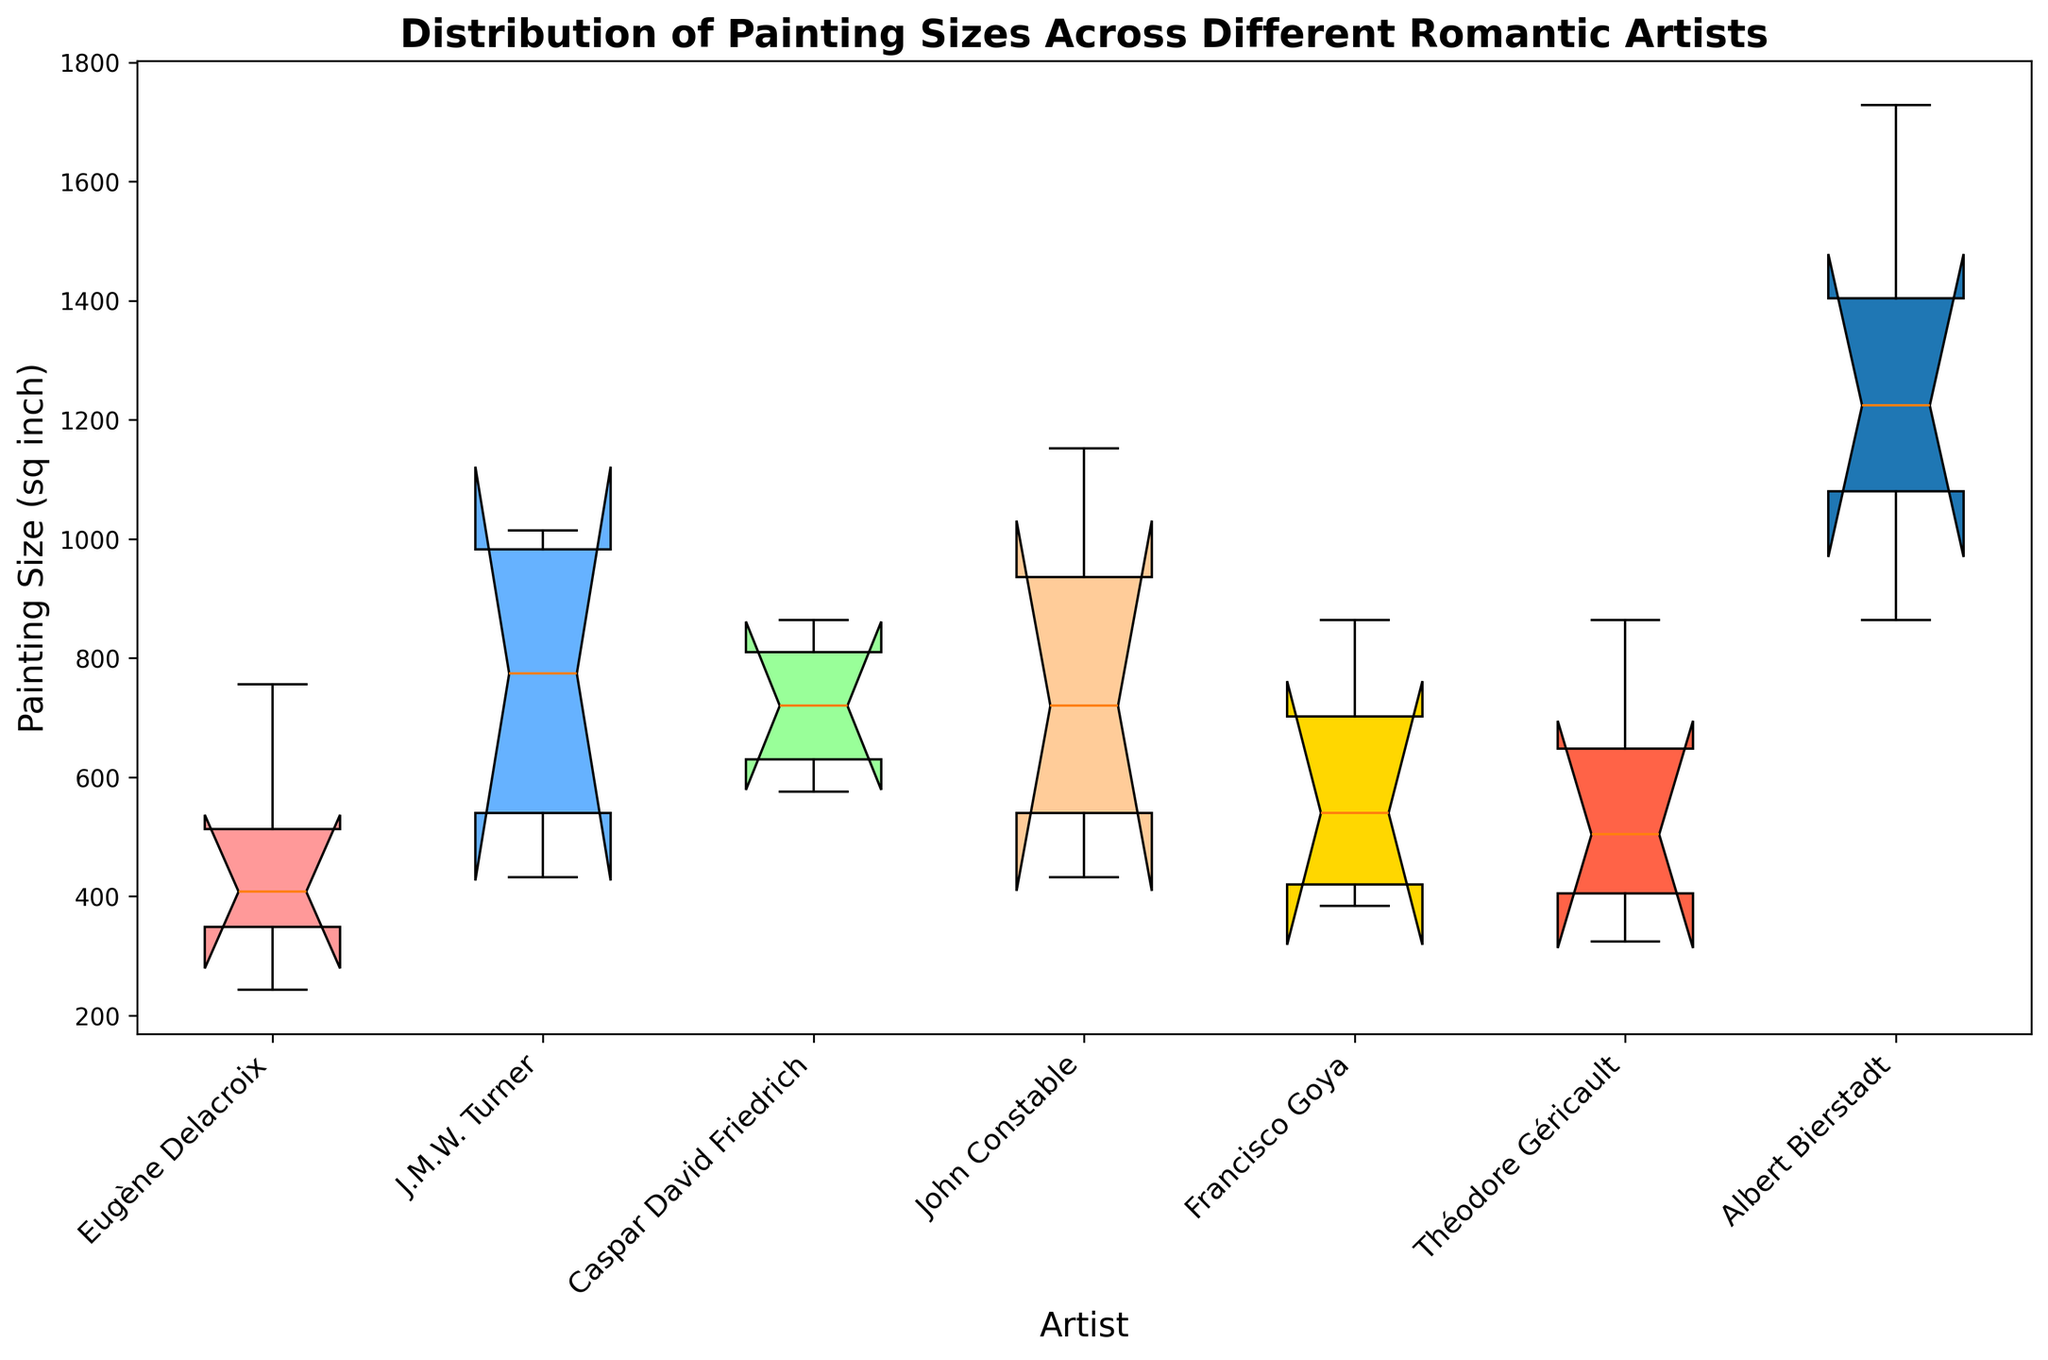What is the median painting size for Eugène Delacroix? To find the median size for Eugène Delacroix, look for the middle value in the sorted list of sizes. The sizes are [243, 384, 432, 756]. Since there are four values, the median is the average of the two middle values: (384 + 432) / 2 = 408.
Answer: 408 Which artist has the largest painting size and what is it? Identify the largest value in the box plot for each artist. Albert Bierstadt has the largest value, which is 1728 square inches.
Answer: Albert Bierstadt, 1728 Who has the smallest variability in painting sizes? The smallest variability is indicated by the box with the least height (smallest interquartile range). Francisco Goya's box has the smallest height, indicating the least variability.
Answer: Francisco Goya Compare the median painting sizes of Caspar David Friedrich and John Constable. Which is larger? Find the median painting size for Caspar David Friedrich and John Constable from their respective boxes. Friedrich's median is approximately in the center of the box, while Constable's median is higher. John Constable's median is larger.
Answer: John Constable Which artist has the widest range of painting sizes? The range is the difference between the maximum and minimum values. Albert Bierstadt has the widest range with sizes ranging from 864 to 1728 square inches.
Answer: Albert Bierstadt What is the interquartile range (IQR) of painting sizes for J.M.W. Turner? The IQR is the difference between the third quartile (Q3) and the first quartile (Q1). Identify Q1 and Q3 from the box of J.M.W. Turner and calculate Q3 - Q1. For example, if Q3 is 972 and Q1 is 432, then IQR would be 972 - 432 = 540.
Answer: 540 Which artist has painting sizes that are most similar to each other? Similarity in sizes is indicated by a smaller interquartile range (IQR) and less spread. By examining the height of the boxes and the distance between the whiskers, Francisco Goya has the most similar-sized paintings.
Answer: Francisco Goya Is there an outlier in Théodore Géricault's painting sizes? An outlier is a data point that is significantly lower or higher than the rest of the data. By checking the ends of the whiskers and any points beyond, Théodore Géricault does not have any noticeable outliers.
Answer: No Which artist's painting size distribution is most skewed? Skewness can be indicated by a larger difference between the median and the quartiles. Upon visual inspection, if the median line is not centered, it indicates skewness. For example, John Constable's distribution appears skewed as the median is closer to the lower quartile.
Answer: John Constable 